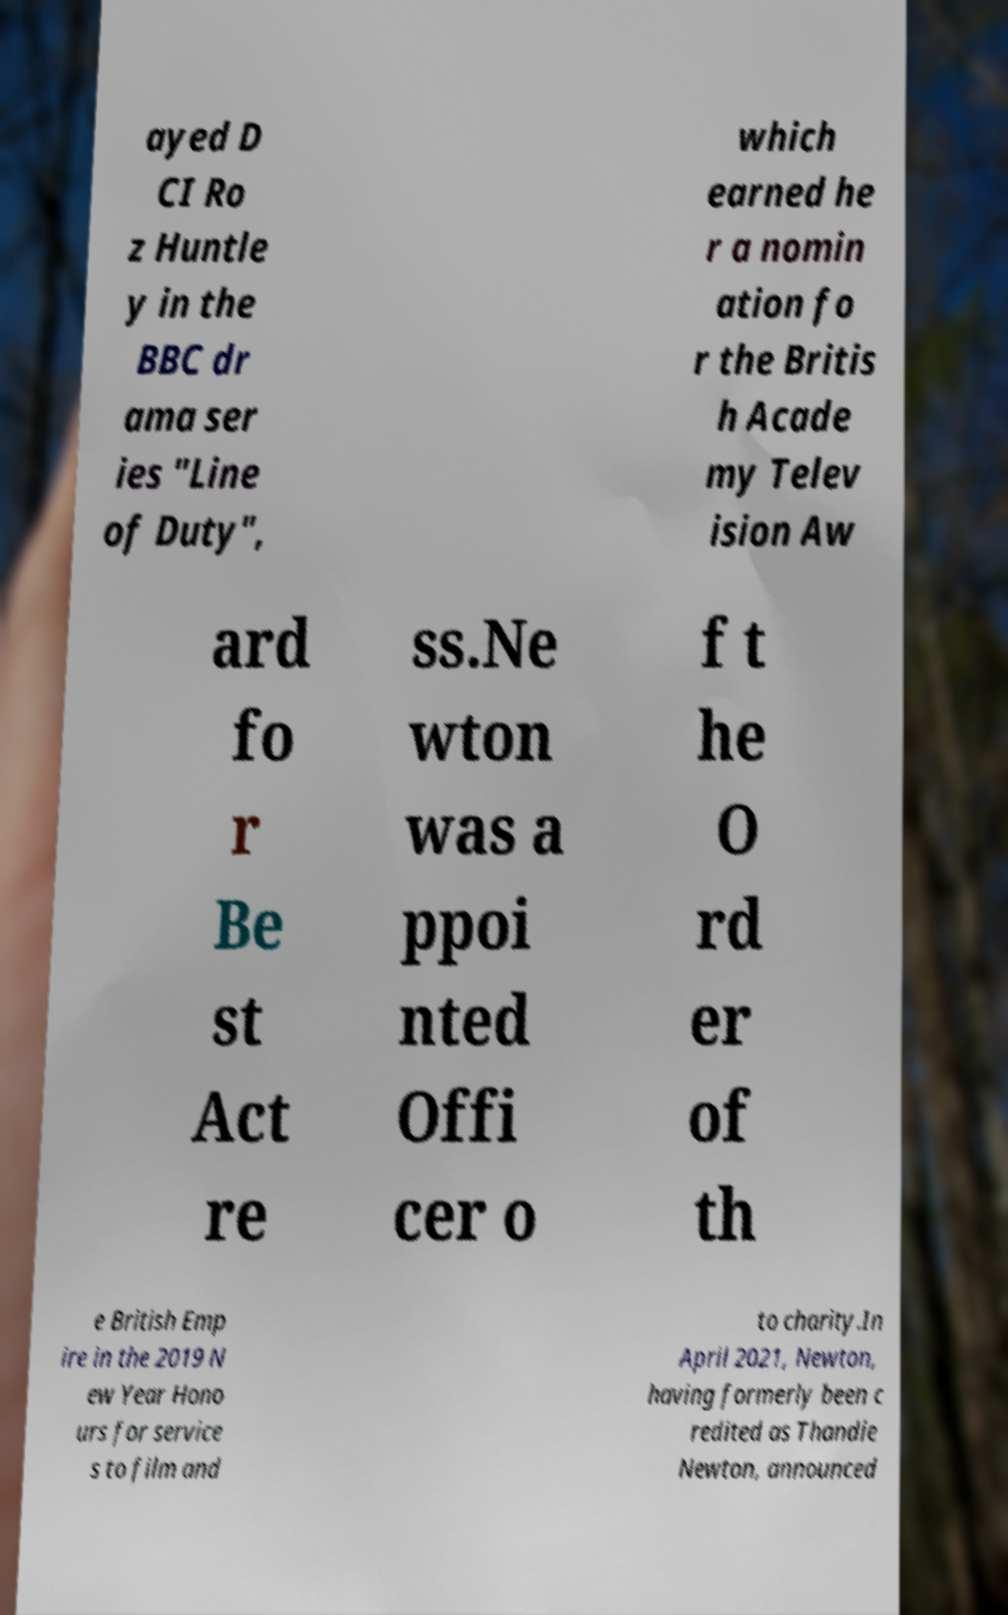Could you extract and type out the text from this image? ayed D CI Ro z Huntle y in the BBC dr ama ser ies "Line of Duty", which earned he r a nomin ation fo r the Britis h Acade my Telev ision Aw ard fo r Be st Act re ss.Ne wton was a ppoi nted Offi cer o f t he O rd er of th e British Emp ire in the 2019 N ew Year Hono urs for service s to film and to charity.In April 2021, Newton, having formerly been c redited as Thandie Newton, announced 